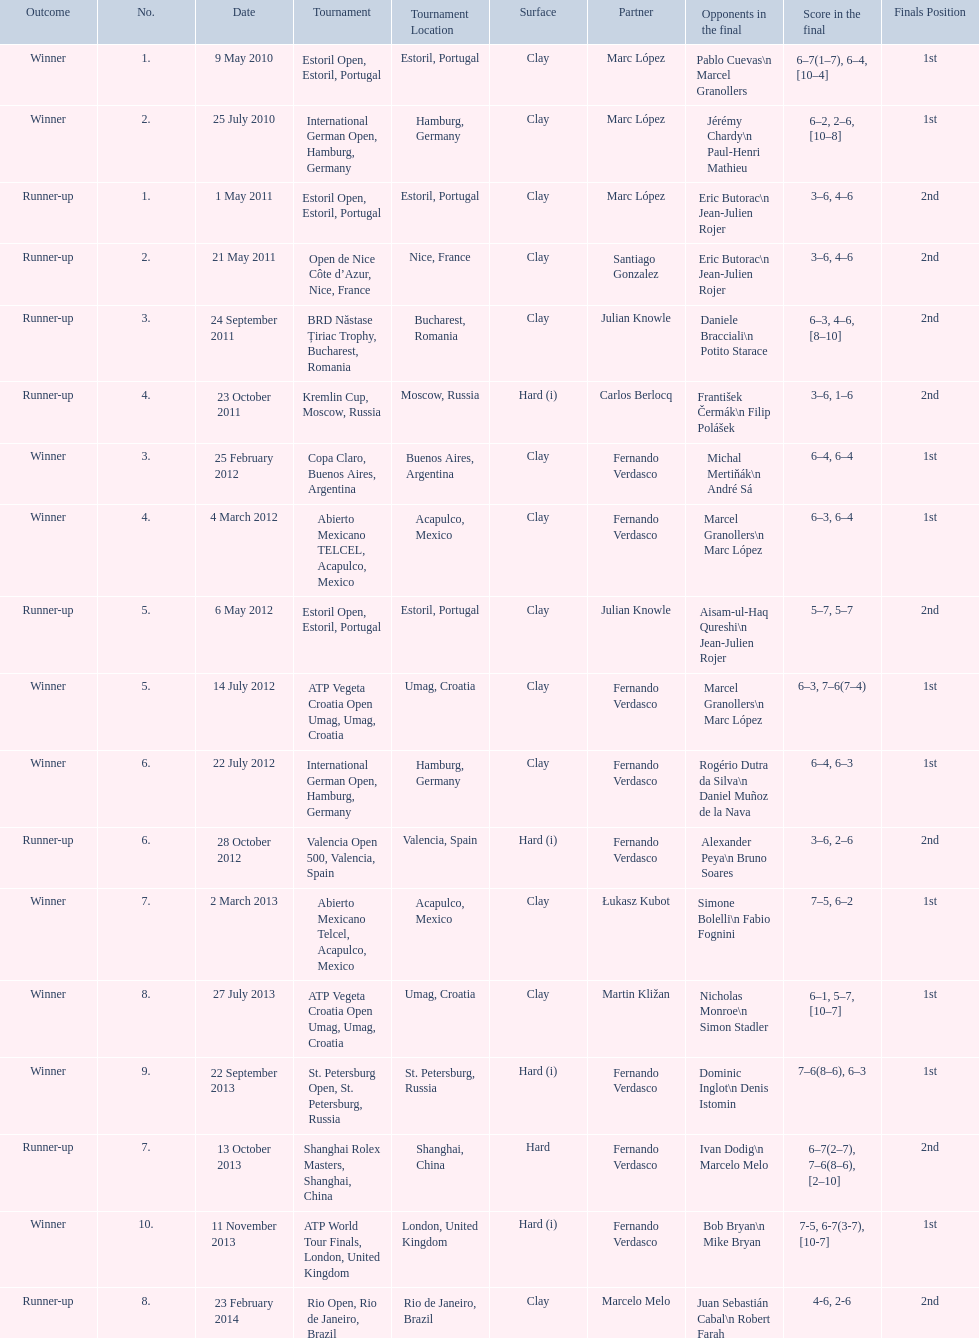How many winners are there? 10. 